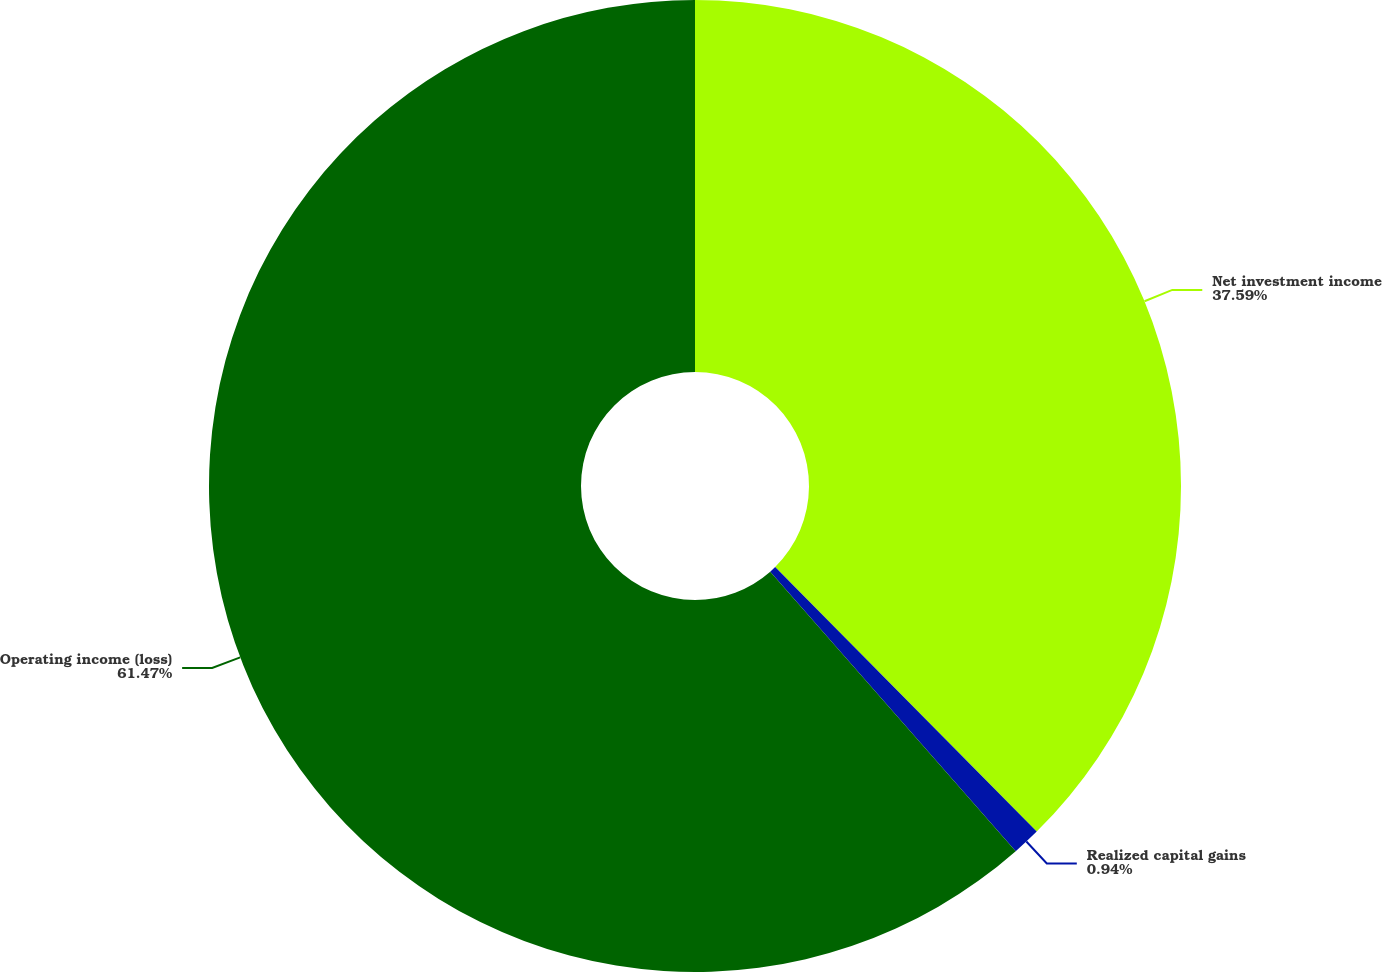Convert chart. <chart><loc_0><loc_0><loc_500><loc_500><pie_chart><fcel>Net investment income<fcel>Realized capital gains<fcel>Operating income (loss)<nl><fcel>37.59%<fcel>0.94%<fcel>61.47%<nl></chart> 